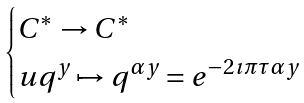Convert formula to latex. <formula><loc_0><loc_0><loc_500><loc_500>\begin{cases} C ^ { * } \rightarrow C ^ { * } \\ u q ^ { y } \mapsto q ^ { \alpha y } = e ^ { - 2 \imath \pi \tau \alpha y } \end{cases}</formula> 